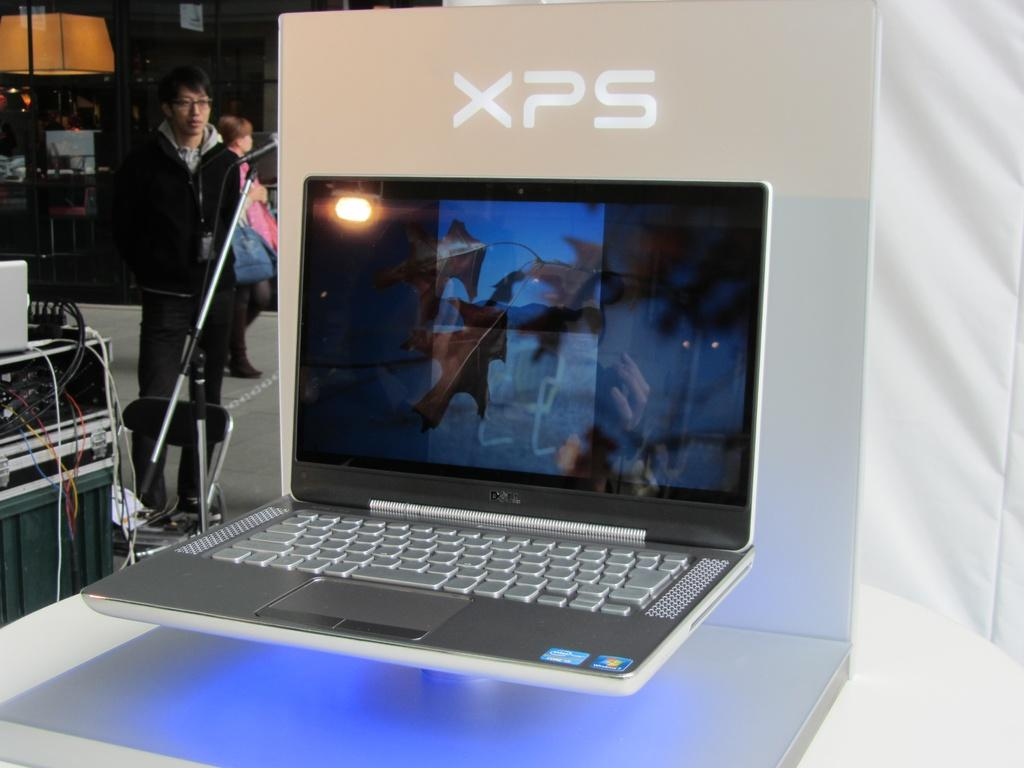Provide a one-sentence caption for the provided image. A display of a Dell XPS laptop computer. 